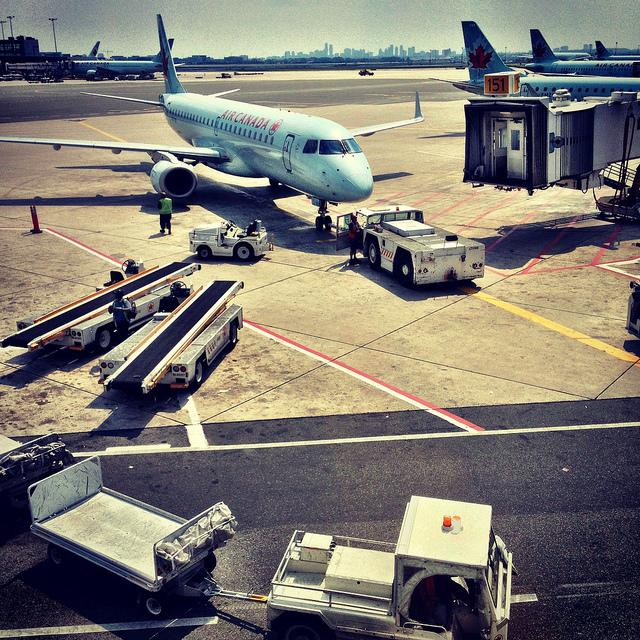What does the vehicle that will be used to move the plane face?

Choices:
A) nothing
B) plane
C) airport side
D) tow truck plane 